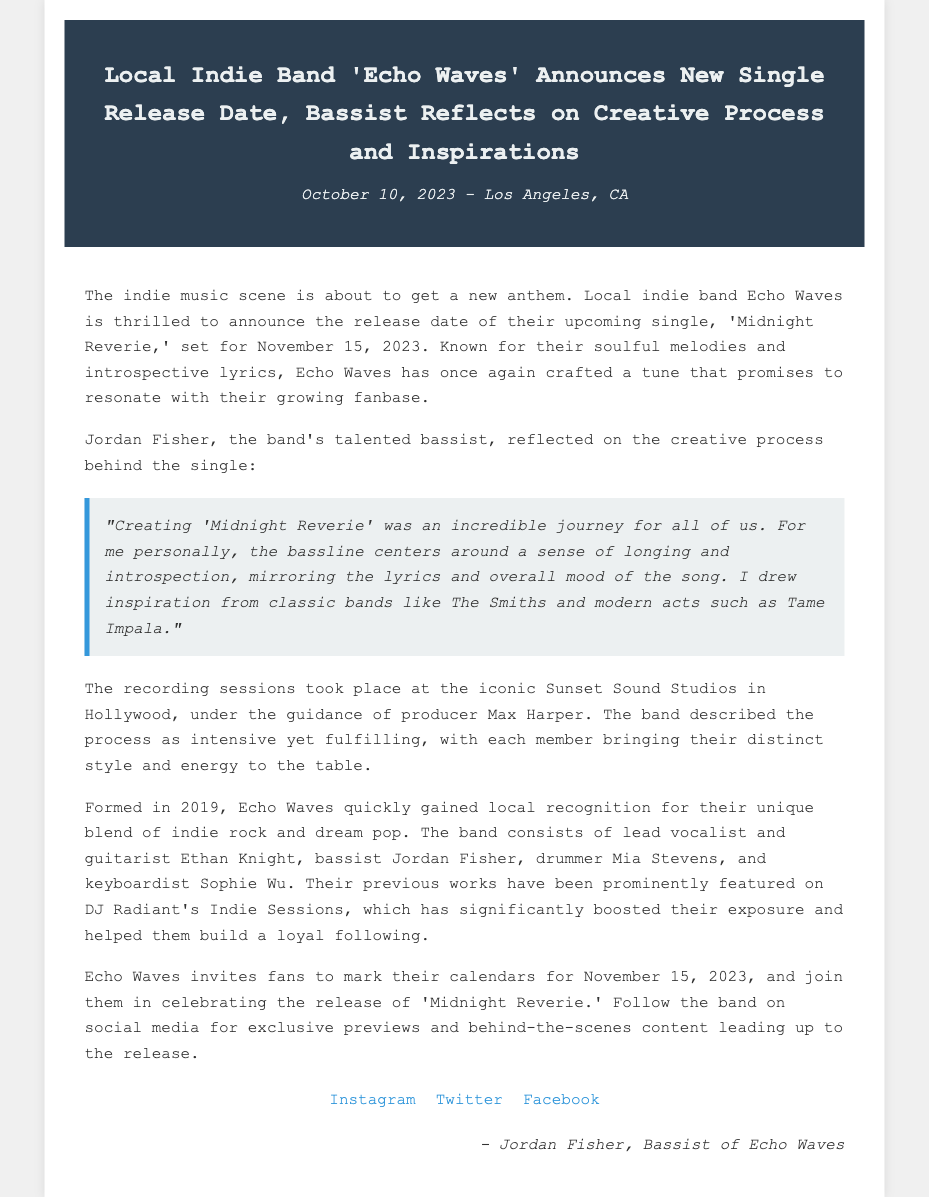What is the title of the new single? The title of the new single is mentioned in the headline of the press release, which is 'Midnight Reverie'.
Answer: 'Midnight Reverie' When is the release date of the single? The release date of the single is provided in the text, which states it will be released on November 15, 2023.
Answer: November 15, 2023 Who produced the recording sessions? The producer of the recording sessions is indicated in the document, which names Max Harper as the producer.
Answer: Max Harper Which classic band inspired the bassist? The bassist mentions drawing inspiration from classic bands in the quote, specifically identifying The Smiths as one of them.
Answer: The Smiths What year was Echo Waves formed? The document states that the band was formed in 2019.
Answer: 2019 How does the bassist describe the creative process? The bassist reflects on the journey of creating the single, describing it as an "incredible journey" in the blockquote.
Answer: Incredible journey What type of music does Echo Waves blend? The document describes their music style as a combination of indie rock and dream pop.
Answer: Indie rock and dream pop What is the role of Jordan Fisher in the band? The text identifies Jordan Fisher's role in the band as the bassist.
Answer: Bassist Where did the recording sessions take place? The location of the recording sessions is mentioned in the document as Sunset Sound Studios in Hollywood.
Answer: Sunset Sound Studios in Hollywood 